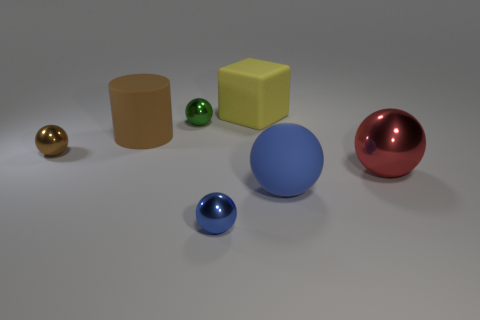Subtract all large matte balls. How many balls are left? 4 Add 1 green cubes. How many objects exist? 8 Subtract all cyan blocks. How many blue balls are left? 2 Subtract 1 cubes. How many cubes are left? 0 Subtract all red balls. How many balls are left? 4 Subtract all spheres. How many objects are left? 2 Subtract 0 blue blocks. How many objects are left? 7 Subtract all red spheres. Subtract all cyan cylinders. How many spheres are left? 4 Subtract all blue matte things. Subtract all blocks. How many objects are left? 5 Add 1 blue metal balls. How many blue metal balls are left? 2 